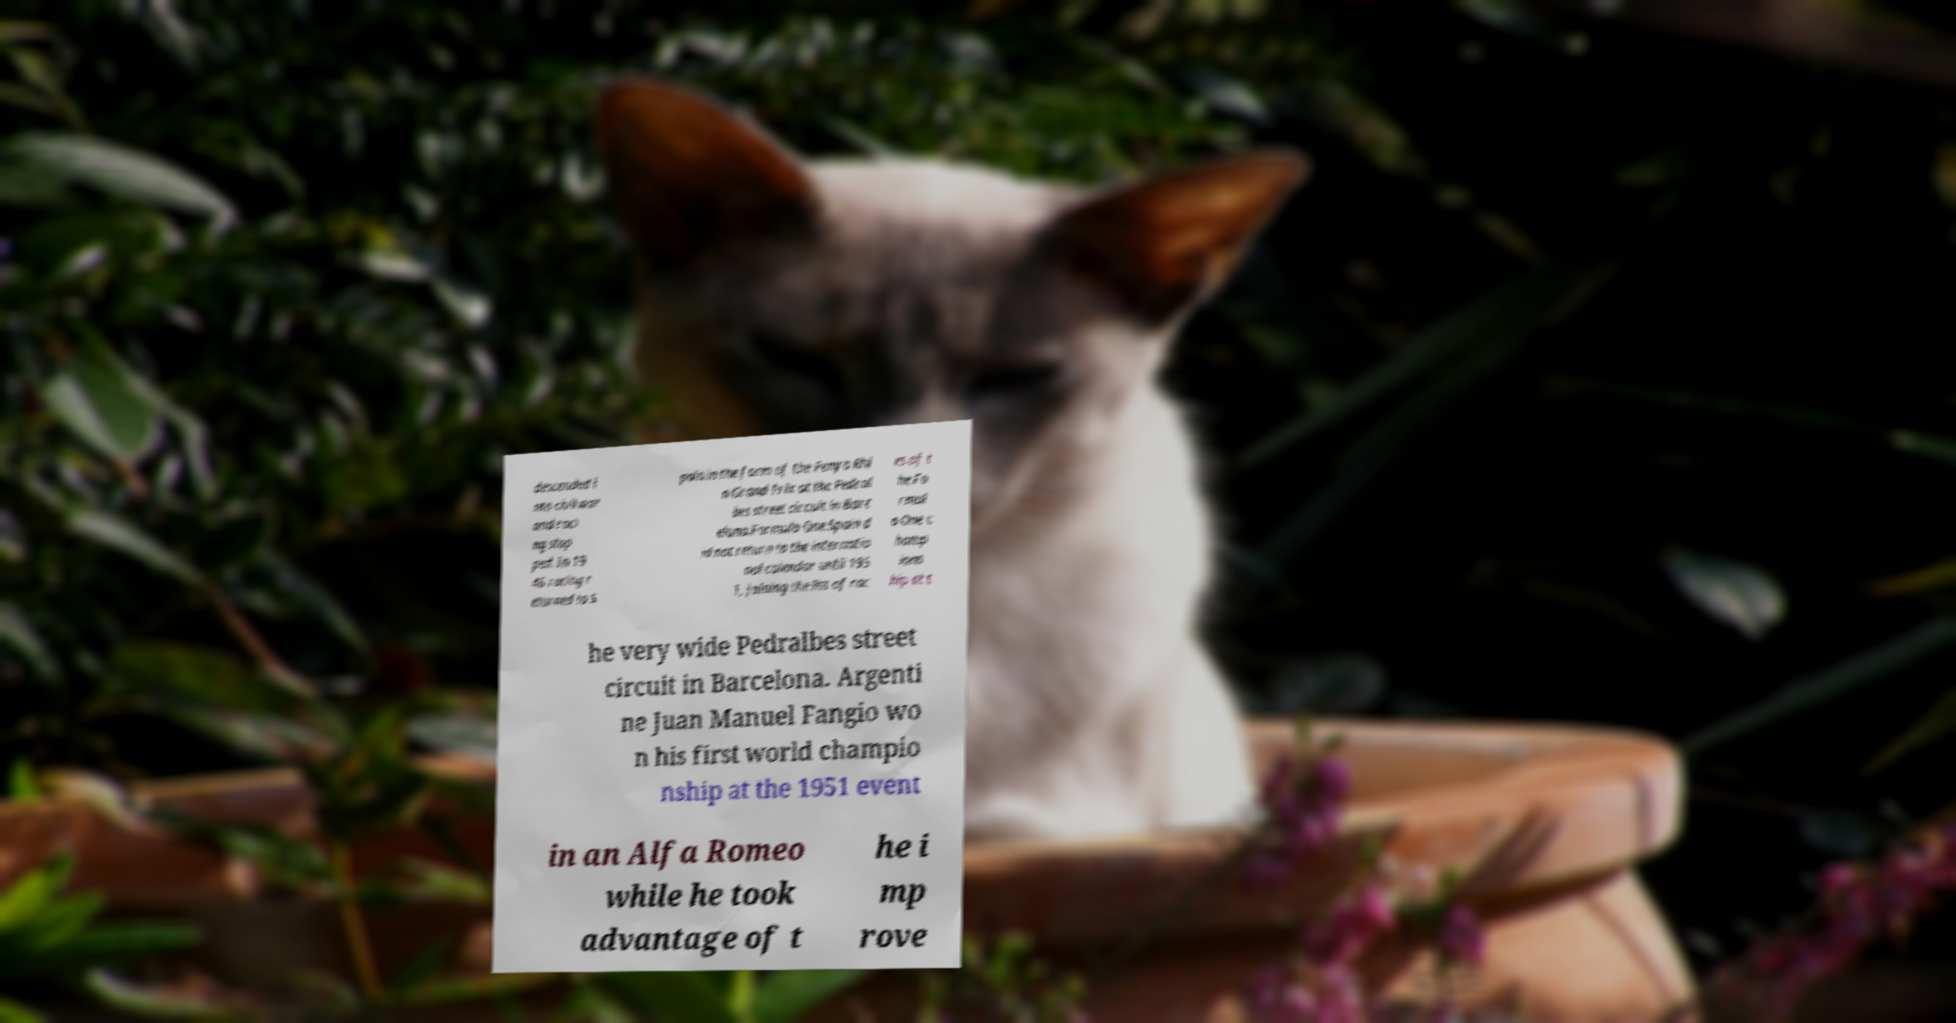For documentation purposes, I need the text within this image transcribed. Could you provide that? descended i nto civil war and raci ng stop ped. In 19 46 racing r eturned to S pain in the form of the Penya Rhi n Grand Prix at the Pedral bes street circuit in Barc elona.Formula One.Spain d id not return to the internatio nal calendar until 195 1, joining the list of rac es of t he Fo rmul a One c hamp ions hip at t he very wide Pedralbes street circuit in Barcelona. Argenti ne Juan Manuel Fangio wo n his first world champio nship at the 1951 event in an Alfa Romeo while he took advantage of t he i mp rove 